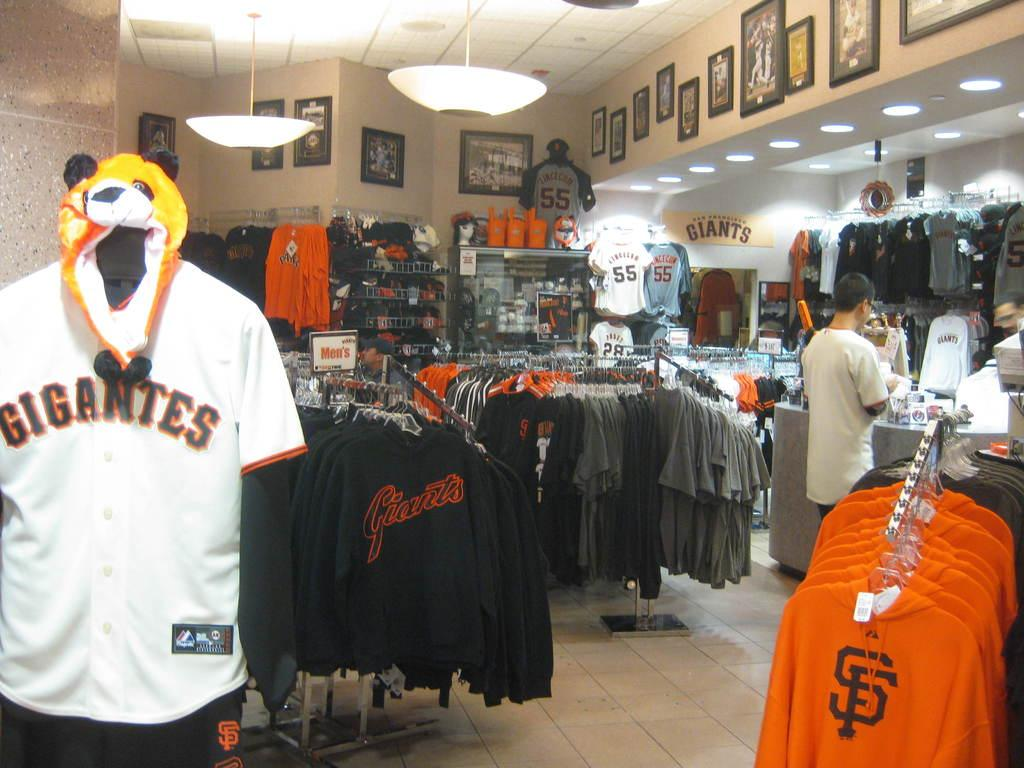Provide a one-sentence caption for the provided image. A number of Giants merchandise is for sale in a store. 